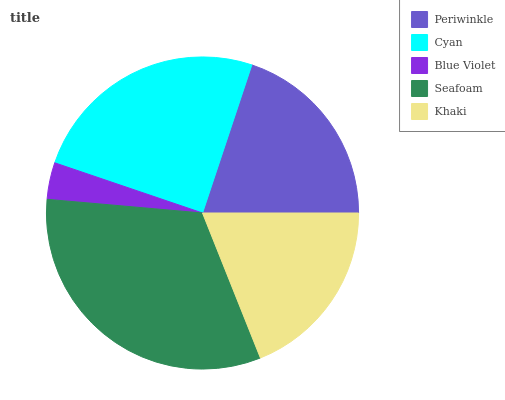Is Blue Violet the minimum?
Answer yes or no. Yes. Is Seafoam the maximum?
Answer yes or no. Yes. Is Cyan the minimum?
Answer yes or no. No. Is Cyan the maximum?
Answer yes or no. No. Is Cyan greater than Periwinkle?
Answer yes or no. Yes. Is Periwinkle less than Cyan?
Answer yes or no. Yes. Is Periwinkle greater than Cyan?
Answer yes or no. No. Is Cyan less than Periwinkle?
Answer yes or no. No. Is Periwinkle the high median?
Answer yes or no. Yes. Is Periwinkle the low median?
Answer yes or no. Yes. Is Cyan the high median?
Answer yes or no. No. Is Seafoam the low median?
Answer yes or no. No. 